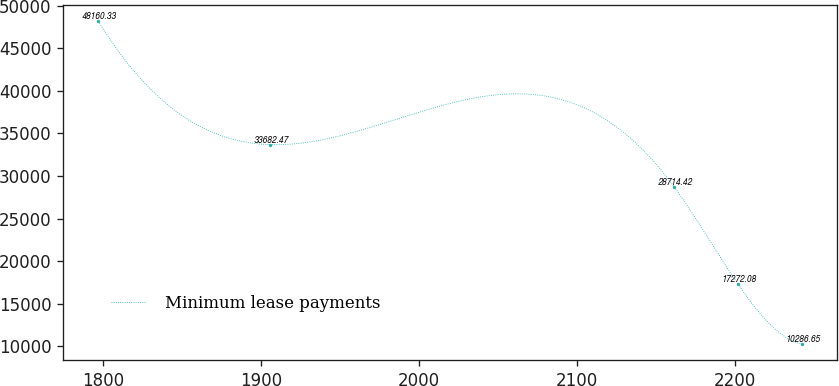Convert chart. <chart><loc_0><loc_0><loc_500><loc_500><line_chart><ecel><fcel>Minimum lease payments<nl><fcel>1796.75<fcel>48160.3<nl><fcel>1905.45<fcel>33682.5<nl><fcel>2161.68<fcel>28714.4<nl><fcel>2202.22<fcel>17272.1<nl><fcel>2242.76<fcel>10286.6<nl></chart> 